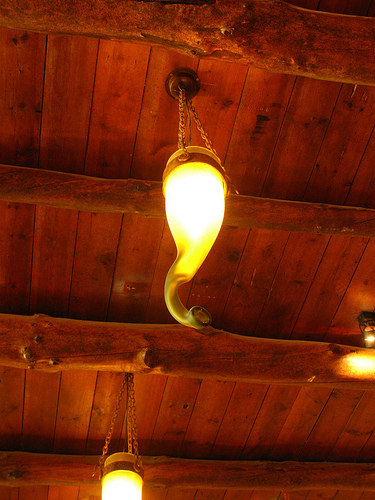<image>
Is there a roof next to the lamp? No. The roof is not positioned next to the lamp. They are located in different areas of the scene. Is there a light behind the lamp? No. The light is not behind the lamp. From this viewpoint, the light appears to be positioned elsewhere in the scene. 